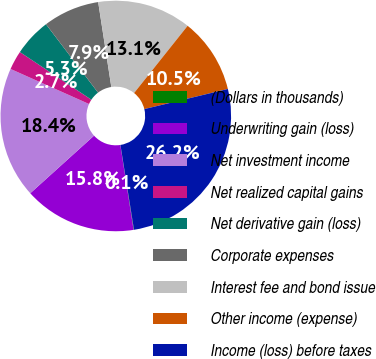Convert chart to OTSL. <chart><loc_0><loc_0><loc_500><loc_500><pie_chart><fcel>(Dollars in thousands)<fcel>Underwriting gain (loss)<fcel>Net investment income<fcel>Net realized capital gains<fcel>Net derivative gain (loss)<fcel>Corporate expenses<fcel>Interest fee and bond issue<fcel>Other income (expense)<fcel>Income (loss) before taxes<nl><fcel>0.06%<fcel>15.77%<fcel>18.38%<fcel>2.67%<fcel>5.29%<fcel>7.91%<fcel>13.15%<fcel>10.53%<fcel>26.24%<nl></chart> 